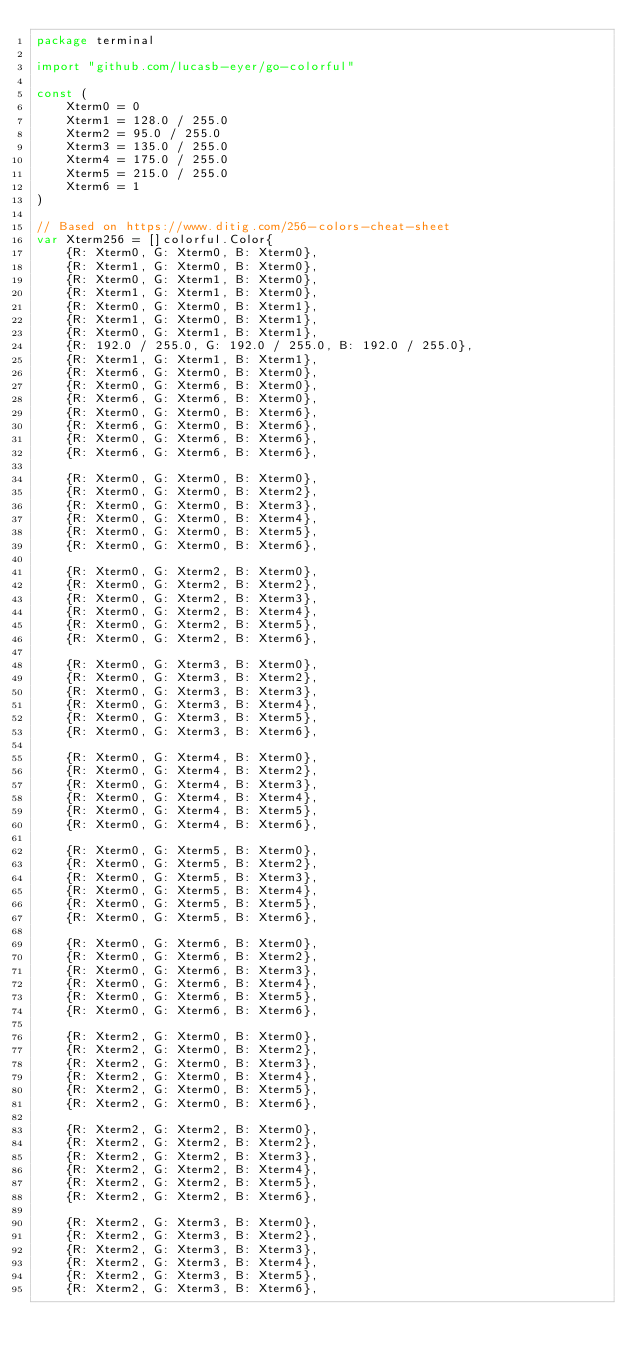Convert code to text. <code><loc_0><loc_0><loc_500><loc_500><_Go_>package terminal

import "github.com/lucasb-eyer/go-colorful"

const (
	Xterm0 = 0
	Xterm1 = 128.0 / 255.0
	Xterm2 = 95.0 / 255.0
	Xterm3 = 135.0 / 255.0
	Xterm4 = 175.0 / 255.0
	Xterm5 = 215.0 / 255.0
	Xterm6 = 1
)

// Based on https://www.ditig.com/256-colors-cheat-sheet
var Xterm256 = []colorful.Color{
	{R: Xterm0, G: Xterm0, B: Xterm0},
	{R: Xterm1, G: Xterm0, B: Xterm0},
	{R: Xterm0, G: Xterm1, B: Xterm0},
	{R: Xterm1, G: Xterm1, B: Xterm0},
	{R: Xterm0, G: Xterm0, B: Xterm1},
	{R: Xterm1, G: Xterm0, B: Xterm1},
	{R: Xterm0, G: Xterm1, B: Xterm1},
	{R: 192.0 / 255.0, G: 192.0 / 255.0, B: 192.0 / 255.0},
	{R: Xterm1, G: Xterm1, B: Xterm1},
	{R: Xterm6, G: Xterm0, B: Xterm0},
	{R: Xterm0, G: Xterm6, B: Xterm0},
	{R: Xterm6, G: Xterm6, B: Xterm0},
	{R: Xterm0, G: Xterm0, B: Xterm6},
	{R: Xterm6, G: Xterm0, B: Xterm6},
	{R: Xterm0, G: Xterm6, B: Xterm6},
	{R: Xterm6, G: Xterm6, B: Xterm6},

	{R: Xterm0, G: Xterm0, B: Xterm0},
	{R: Xterm0, G: Xterm0, B: Xterm2},
	{R: Xterm0, G: Xterm0, B: Xterm3},
	{R: Xterm0, G: Xterm0, B: Xterm4},
	{R: Xterm0, G: Xterm0, B: Xterm5},
	{R: Xterm0, G: Xterm0, B: Xterm6},

	{R: Xterm0, G: Xterm2, B: Xterm0},
	{R: Xterm0, G: Xterm2, B: Xterm2},
	{R: Xterm0, G: Xterm2, B: Xterm3},
	{R: Xterm0, G: Xterm2, B: Xterm4},
	{R: Xterm0, G: Xterm2, B: Xterm5},
	{R: Xterm0, G: Xterm2, B: Xterm6},

	{R: Xterm0, G: Xterm3, B: Xterm0},
	{R: Xterm0, G: Xterm3, B: Xterm2},
	{R: Xterm0, G: Xterm3, B: Xterm3},
	{R: Xterm0, G: Xterm3, B: Xterm4},
	{R: Xterm0, G: Xterm3, B: Xterm5},
	{R: Xterm0, G: Xterm3, B: Xterm6},

	{R: Xterm0, G: Xterm4, B: Xterm0},
	{R: Xterm0, G: Xterm4, B: Xterm2},
	{R: Xterm0, G: Xterm4, B: Xterm3},
	{R: Xterm0, G: Xterm4, B: Xterm4},
	{R: Xterm0, G: Xterm4, B: Xterm5},
	{R: Xterm0, G: Xterm4, B: Xterm6},

	{R: Xterm0, G: Xterm5, B: Xterm0},
	{R: Xterm0, G: Xterm5, B: Xterm2},
	{R: Xterm0, G: Xterm5, B: Xterm3},
	{R: Xterm0, G: Xterm5, B: Xterm4},
	{R: Xterm0, G: Xterm5, B: Xterm5},
	{R: Xterm0, G: Xterm5, B: Xterm6},

	{R: Xterm0, G: Xterm6, B: Xterm0},
	{R: Xterm0, G: Xterm6, B: Xterm2},
	{R: Xterm0, G: Xterm6, B: Xterm3},
	{R: Xterm0, G: Xterm6, B: Xterm4},
	{R: Xterm0, G: Xterm6, B: Xterm5},
	{R: Xterm0, G: Xterm6, B: Xterm6},

	{R: Xterm2, G: Xterm0, B: Xterm0},
	{R: Xterm2, G: Xterm0, B: Xterm2},
	{R: Xterm2, G: Xterm0, B: Xterm3},
	{R: Xterm2, G: Xterm0, B: Xterm4},
	{R: Xterm2, G: Xterm0, B: Xterm5},
	{R: Xterm2, G: Xterm0, B: Xterm6},

	{R: Xterm2, G: Xterm2, B: Xterm0},
	{R: Xterm2, G: Xterm2, B: Xterm2},
	{R: Xterm2, G: Xterm2, B: Xterm3},
	{R: Xterm2, G: Xterm2, B: Xterm4},
	{R: Xterm2, G: Xterm2, B: Xterm5},
	{R: Xterm2, G: Xterm2, B: Xterm6},

	{R: Xterm2, G: Xterm3, B: Xterm0},
	{R: Xterm2, G: Xterm3, B: Xterm2},
	{R: Xterm2, G: Xterm3, B: Xterm3},
	{R: Xterm2, G: Xterm3, B: Xterm4},
	{R: Xterm2, G: Xterm3, B: Xterm5},
	{R: Xterm2, G: Xterm3, B: Xterm6},
</code> 